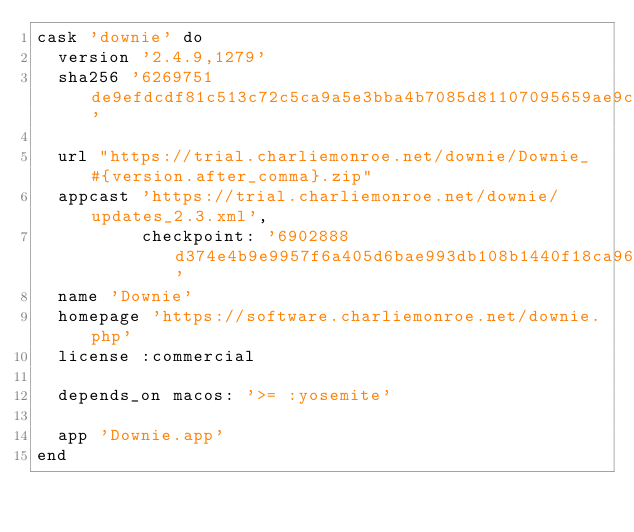<code> <loc_0><loc_0><loc_500><loc_500><_Ruby_>cask 'downie' do
  version '2.4.9,1279'
  sha256 '6269751de9efdcdf81c513c72c5ca9a5e3bba4b7085d81107095659ae9cf9456'

  url "https://trial.charliemonroe.net/downie/Downie_#{version.after_comma}.zip"
  appcast 'https://trial.charliemonroe.net/downie/updates_2.3.xml',
          checkpoint: '6902888d374e4b9e9957f6a405d6bae993db108b1440f18ca964e1824054675b'
  name 'Downie'
  homepage 'https://software.charliemonroe.net/downie.php'
  license :commercial

  depends_on macos: '>= :yosemite'

  app 'Downie.app'
end
</code> 